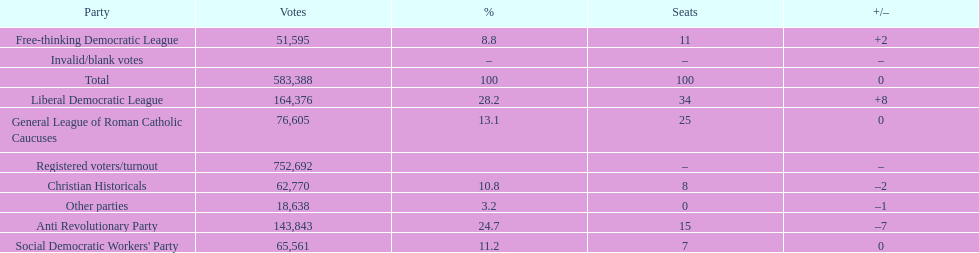Name the top three parties? Liberal Democratic League, Anti Revolutionary Party, General League of Roman Catholic Caucuses. 